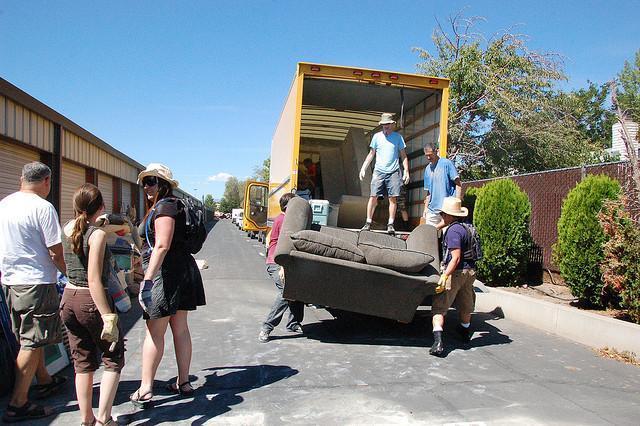How many men are in the truck?
Give a very brief answer. 2. How many people are visible?
Give a very brief answer. 6. How many elephants are pictured?
Give a very brief answer. 0. 